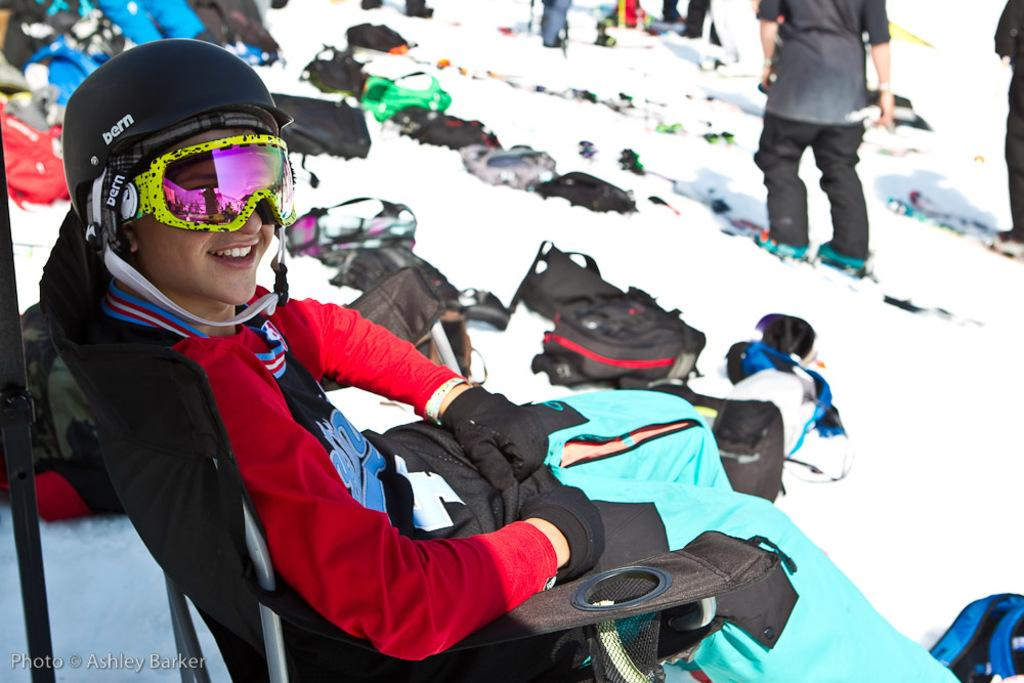What is the woman in the image doing? The woman is sitting on a chair in the image. What is the setting of the image? The scene is covered in snow. What objects can be seen near the woman? There are bags visible in the image. How many people are present in the image? There are people present in the image. What rule is being discussed by the committee in the image? There is no committee or rule present in the image; it features a woman sitting on a chair in a snowy scene with bags and other people. Is there a stream visible in the image? There is no stream present in the image; it is set in a snowy scene with a woman sitting on a chair, bags, and other people. 